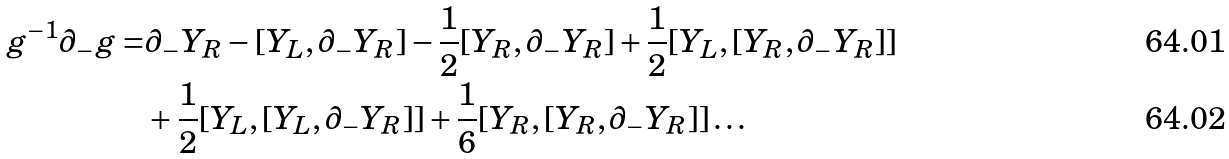Convert formula to latex. <formula><loc_0><loc_0><loc_500><loc_500>g ^ { - 1 } \partial _ { - } g = & \partial _ { - } Y _ { R } - [ Y _ { L } , \partial _ { - } Y _ { R } ] - \frac { 1 } { 2 } [ Y _ { R } , \partial _ { - } Y _ { R } ] + \frac { 1 } { 2 } [ Y _ { L } , [ Y _ { R } , \partial _ { - } Y _ { R } ] ] \\ & + \frac { 1 } { 2 } [ Y _ { L } , [ Y _ { L } , \partial _ { - } Y _ { R } ] ] + \frac { 1 } { 6 } [ Y _ { R } , [ Y _ { R } , \partial _ { - } Y _ { R } ] ] \dots</formula> 